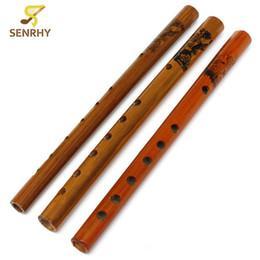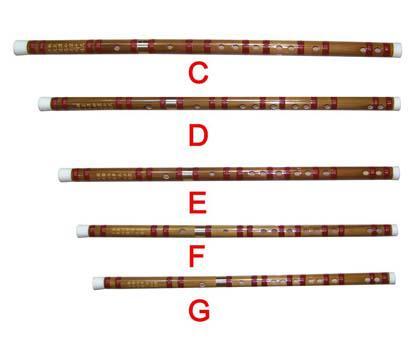The first image is the image on the left, the second image is the image on the right. Evaluate the accuracy of this statement regarding the images: "There are exactly two flutes.". Is it true? Answer yes or no. No. The first image is the image on the left, the second image is the image on the right. For the images shown, is this caption "Each image features one bamboo flute displayed diagonally so one end is on the upper right." true? Answer yes or no. No. 